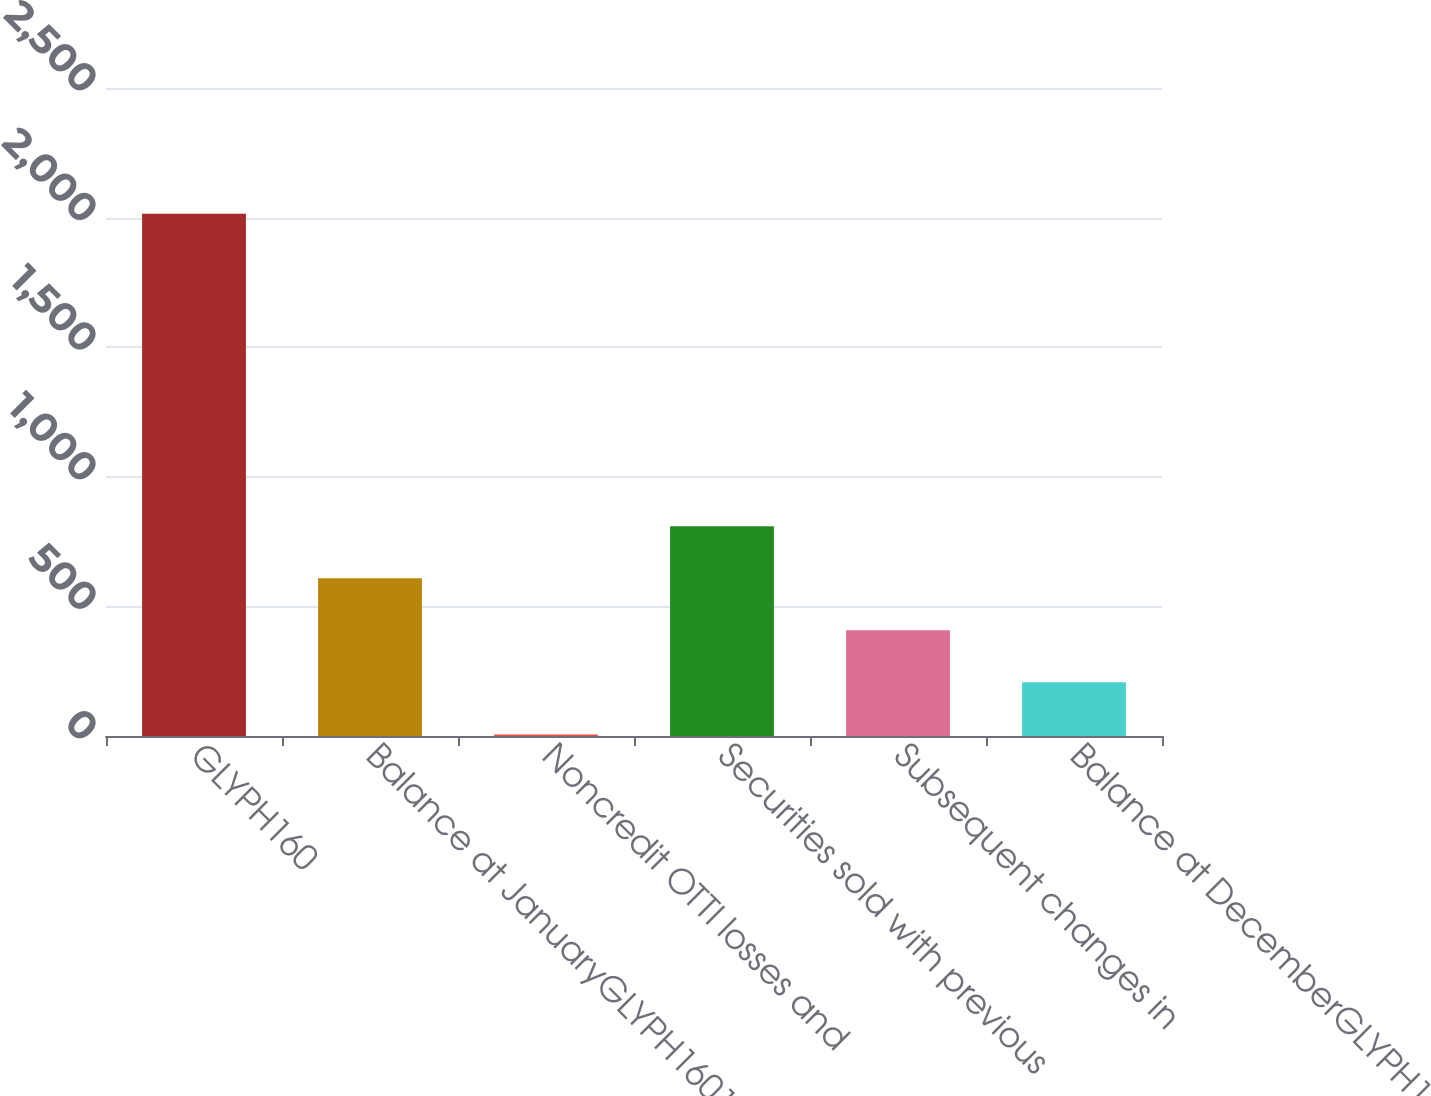<chart> <loc_0><loc_0><loc_500><loc_500><bar_chart><fcel>GLYPH160<fcel>Balance at JanuaryGLYPH1601<fcel>Noncredit OTTI losses and<fcel>Securities sold with previous<fcel>Subsequent changes in<fcel>Balance at DecemberGLYPH16031<nl><fcel>2015<fcel>608.7<fcel>6<fcel>809.6<fcel>407.8<fcel>206.9<nl></chart> 